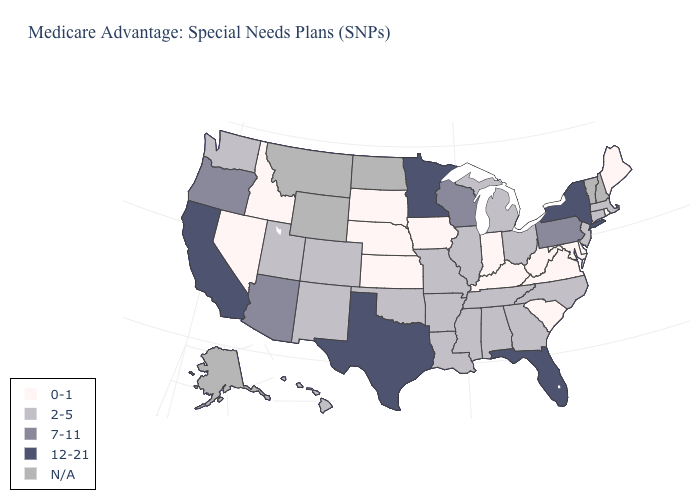What is the highest value in the USA?
Concise answer only. 12-21. What is the value of Virginia?
Write a very short answer. 0-1. What is the lowest value in the South?
Give a very brief answer. 0-1. Which states have the highest value in the USA?
Answer briefly. California, Florida, Minnesota, New York, Texas. Does Arkansas have the highest value in the South?
Concise answer only. No. Name the states that have a value in the range 2-5?
Keep it brief. Alabama, Arkansas, Colorado, Connecticut, Georgia, Hawaii, Illinois, Louisiana, Massachusetts, Michigan, Missouri, Mississippi, North Carolina, New Jersey, New Mexico, Ohio, Oklahoma, Tennessee, Utah, Washington. Name the states that have a value in the range 0-1?
Give a very brief answer. Delaware, Iowa, Idaho, Indiana, Kansas, Kentucky, Maryland, Maine, Nebraska, Nevada, Rhode Island, South Carolina, South Dakota, Virginia, West Virginia. Which states have the lowest value in the USA?
Answer briefly. Delaware, Iowa, Idaho, Indiana, Kansas, Kentucky, Maryland, Maine, Nebraska, Nevada, Rhode Island, South Carolina, South Dakota, Virginia, West Virginia. Name the states that have a value in the range 12-21?
Write a very short answer. California, Florida, Minnesota, New York, Texas. Which states hav the highest value in the MidWest?
Concise answer only. Minnesota. Which states have the highest value in the USA?
Be succinct. California, Florida, Minnesota, New York, Texas. Name the states that have a value in the range 2-5?
Quick response, please. Alabama, Arkansas, Colorado, Connecticut, Georgia, Hawaii, Illinois, Louisiana, Massachusetts, Michigan, Missouri, Mississippi, North Carolina, New Jersey, New Mexico, Ohio, Oklahoma, Tennessee, Utah, Washington. Name the states that have a value in the range 0-1?
Be succinct. Delaware, Iowa, Idaho, Indiana, Kansas, Kentucky, Maryland, Maine, Nebraska, Nevada, Rhode Island, South Carolina, South Dakota, Virginia, West Virginia. 